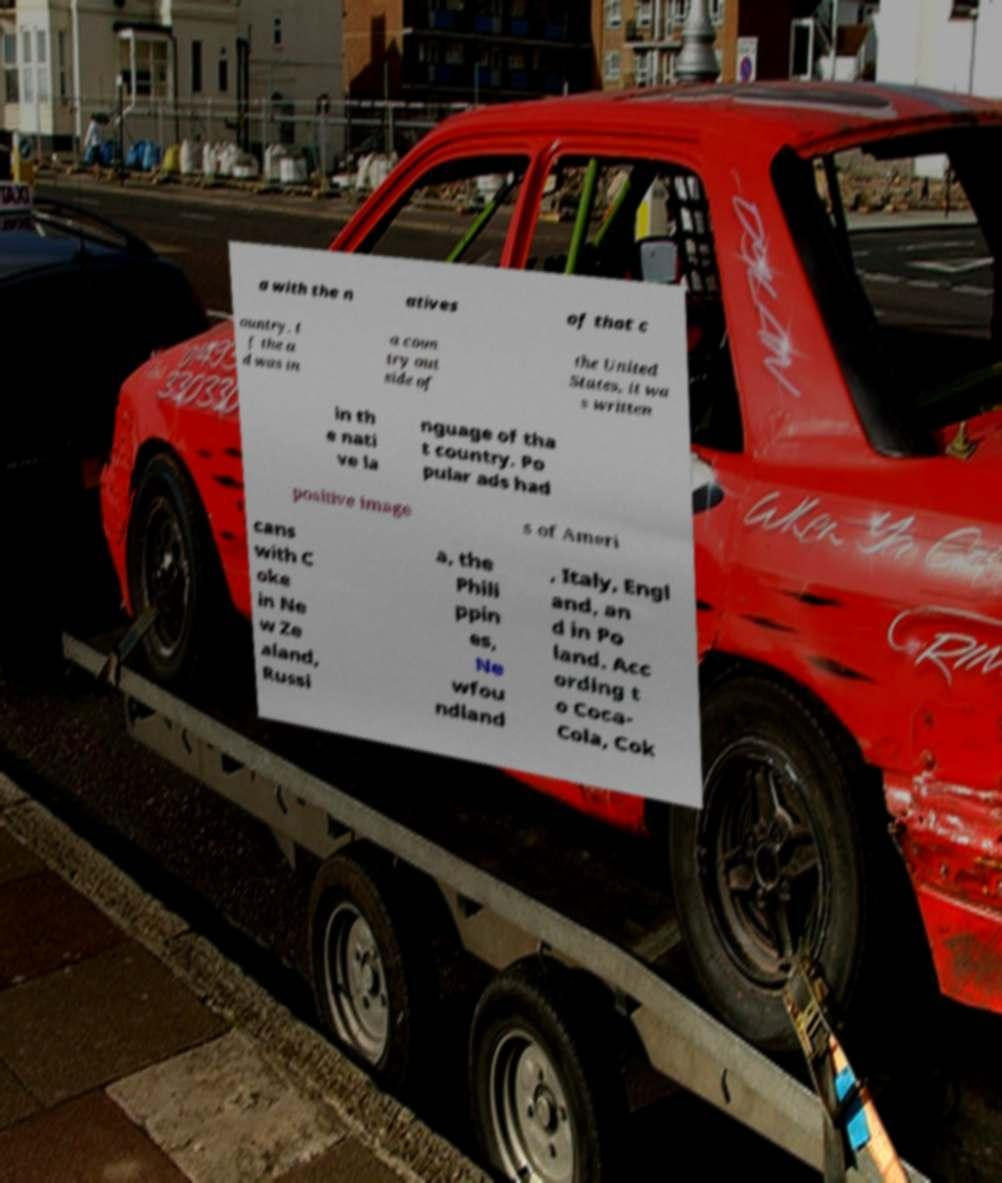I need the written content from this picture converted into text. Can you do that? a with the n atives of that c ountry. I f the a d was in a coun try out side of the United States, it wa s written in th e nati ve la nguage of tha t country. Po pular ads had positive image s of Ameri cans with C oke in Ne w Ze aland, Russi a, the Phili ppin es, Ne wfou ndland , Italy, Engl and, an d in Po land. Acc ording t o Coca- Cola, Cok 